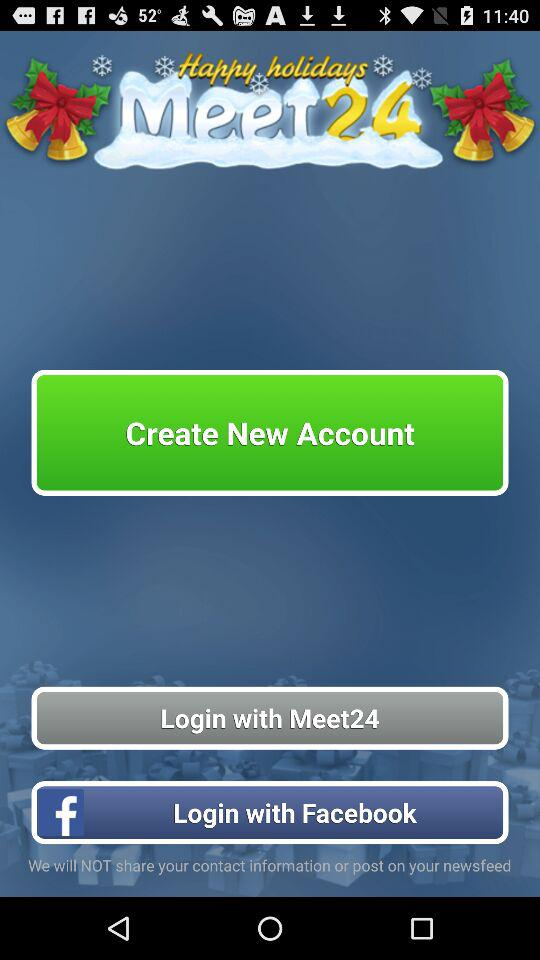How long does it take to log in with "Meet24"?
When the provided information is insufficient, respond with <no answer>. <no answer> 